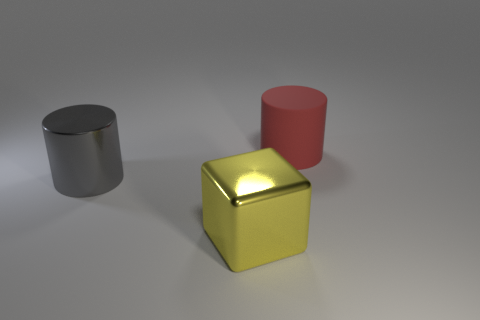There is a yellow thing; how many big gray metallic objects are to the left of it?
Offer a very short reply. 1. Are there more yellow rubber cylinders than gray metallic objects?
Provide a succinct answer. No. The thing that is behind the yellow metallic block and in front of the red cylinder has what shape?
Keep it short and to the point. Cylinder. Is there a matte sphere?
Provide a short and direct response. No. What material is the other thing that is the same shape as the gray metal object?
Ensure brevity in your answer.  Rubber. There is a metallic object that is in front of the big cylinder to the left of the red thing behind the gray metal cylinder; what is its shape?
Your answer should be very brief. Cube. How many other shiny objects have the same shape as the large red object?
Ensure brevity in your answer.  1. There is a gray object that is the same size as the yellow shiny block; what is its material?
Your answer should be compact. Metal. Are there any red cylinders of the same size as the gray shiny cylinder?
Ensure brevity in your answer.  Yes. Are there fewer shiny cylinders in front of the metal block than brown cubes?
Provide a short and direct response. No. 